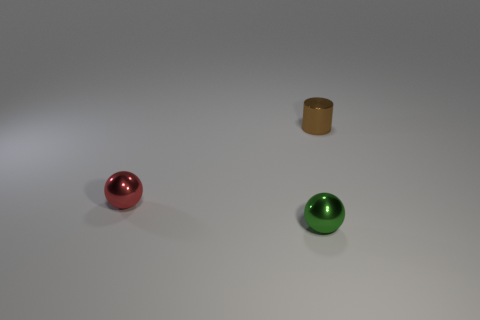There is a small thing that is in front of the small metallic thing that is to the left of the shiny sphere that is in front of the small red ball; what shape is it?
Offer a very short reply. Sphere. There is a thing in front of the red metal ball; is it the same size as the small red thing?
Keep it short and to the point. Yes. There is a object that is both in front of the metal cylinder and right of the tiny red ball; what is its shape?
Offer a terse response. Sphere. The tiny metal sphere in front of the tiny sphere that is behind the tiny green metal ball in front of the red thing is what color?
Provide a short and direct response. Green. There is another thing that is the same shape as the tiny green metal thing; what is its color?
Ensure brevity in your answer.  Red. Are there the same number of balls that are in front of the tiny green metal object and small red matte spheres?
Offer a very short reply. Yes. What number of balls are brown things or small things?
Offer a very short reply. 2. What color is the tiny sphere that is made of the same material as the tiny red object?
Your answer should be compact. Green. Do the brown cylinder and the sphere on the right side of the small red shiny thing have the same material?
Give a very brief answer. Yes. What number of objects are small shiny cylinders or purple rubber objects?
Your answer should be compact. 1. 